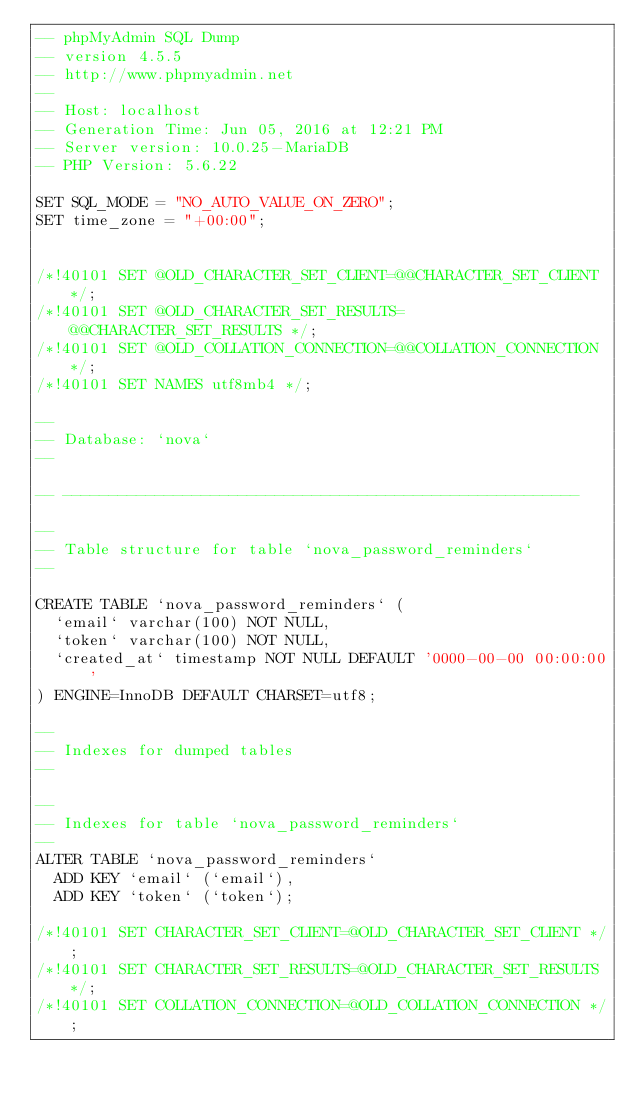Convert code to text. <code><loc_0><loc_0><loc_500><loc_500><_SQL_>-- phpMyAdmin SQL Dump
-- version 4.5.5
-- http://www.phpmyadmin.net
--
-- Host: localhost
-- Generation Time: Jun 05, 2016 at 12:21 PM
-- Server version: 10.0.25-MariaDB
-- PHP Version: 5.6.22

SET SQL_MODE = "NO_AUTO_VALUE_ON_ZERO";
SET time_zone = "+00:00";


/*!40101 SET @OLD_CHARACTER_SET_CLIENT=@@CHARACTER_SET_CLIENT */;
/*!40101 SET @OLD_CHARACTER_SET_RESULTS=@@CHARACTER_SET_RESULTS */;
/*!40101 SET @OLD_COLLATION_CONNECTION=@@COLLATION_CONNECTION */;
/*!40101 SET NAMES utf8mb4 */;

--
-- Database: `nova`
--

-- --------------------------------------------------------

--
-- Table structure for table `nova_password_reminders`
--

CREATE TABLE `nova_password_reminders` (
  `email` varchar(100) NOT NULL,
  `token` varchar(100) NOT NULL,
  `created_at` timestamp NOT NULL DEFAULT '0000-00-00 00:00:00'
) ENGINE=InnoDB DEFAULT CHARSET=utf8;

--
-- Indexes for dumped tables
--

--
-- Indexes for table `nova_password_reminders`
--
ALTER TABLE `nova_password_reminders`
  ADD KEY `email` (`email`),
  ADD KEY `token` (`token`);

/*!40101 SET CHARACTER_SET_CLIENT=@OLD_CHARACTER_SET_CLIENT */;
/*!40101 SET CHARACTER_SET_RESULTS=@OLD_CHARACTER_SET_RESULTS */;
/*!40101 SET COLLATION_CONNECTION=@OLD_COLLATION_CONNECTION */;
</code> 